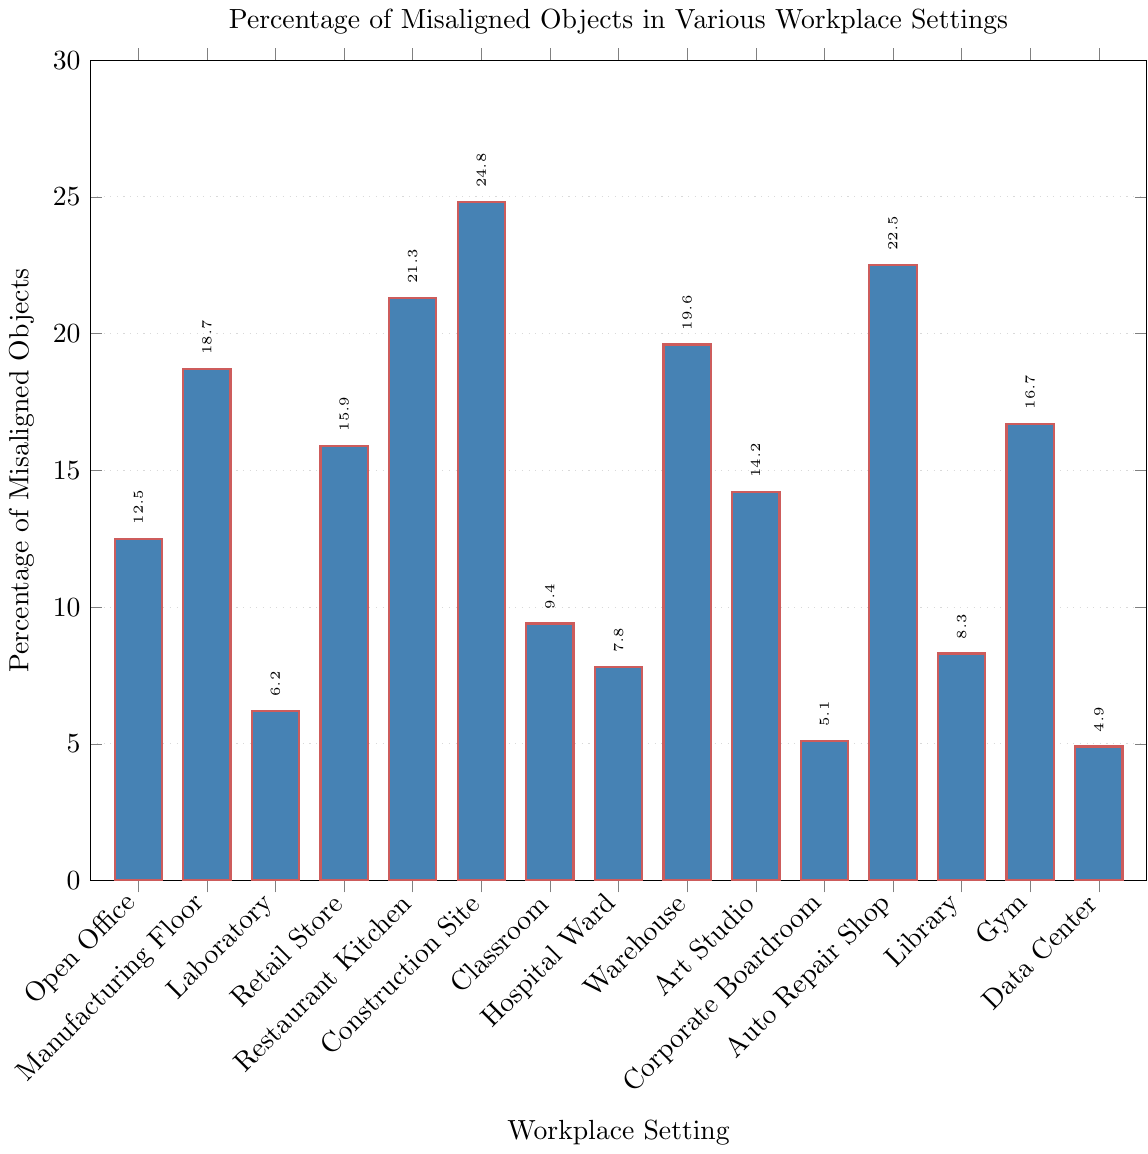What percentage of misaligned objects are found in the Corporate Boardroom setting? Find the bar labeled "Corporate Boardroom" on the x-axis and read the corresponding value on the y-axis.
Answer: 5.1 Among Restaurant Kitchen, Construction Site, and Auto Repair Shop, which setting has the highest percentage of misaligned objects? Compare the heights of the bars for Restaurant Kitchen, Construction Site, and Auto Repair Shop on the x-axis.
Answer: Construction Site Which setting has the lowest percentage of misaligned objects? Identify the bar with the smallest height and read the corresponding setting on the x-axis.
Answer: Data Center Is the percentage of misaligned objects in the Manufacturing Floor greater than in the Retail Store? Compare the heights of the bars for Manufacturing Floor and Retail Store on the x-axis.
Answer: Yes Which workplace setting has a percentage value closest to 15? Identify the bar with a percentage value nearest to 15 by comparing the bars' heights to the 15% mark on the y-axis.
Answer: Retail Store What is the total percentage of misaligned objects in Laboratory, Classroom, and Hospital Ward? Add the percentages for Laboratory (6.2), Classroom (9.4), and Hospital Ward (7.8): 6.2 + 9.4 + 7.8.
Answer: 23.4 What's the average percentage of misaligned objects across all settings? Sum all the given percentages and divide by the number of settings (15). Total: 198, Average: 198/15.
Answer: 13.2 Are there more workplace settings with percentages below 10 or above 20 of misaligned objects? Count the settings below 10 and above 20 and compare the quantities. Below 10: Open Office, Laboratory, Classroom, Hospital Ward, Corporate Boardroom, Data Center, Library. Above 20: Restaurant Kitchen, Construction Site, Auto Repair Shop.
Answer: More below 10 Which setting has a misalignment percentage closer to that of Gym, the Art Studio or the Open Office? Compare the percentage values of Gym (16.7) to Art Studio (14.2) and Open Office (12.5).
Answer: Art Studio 